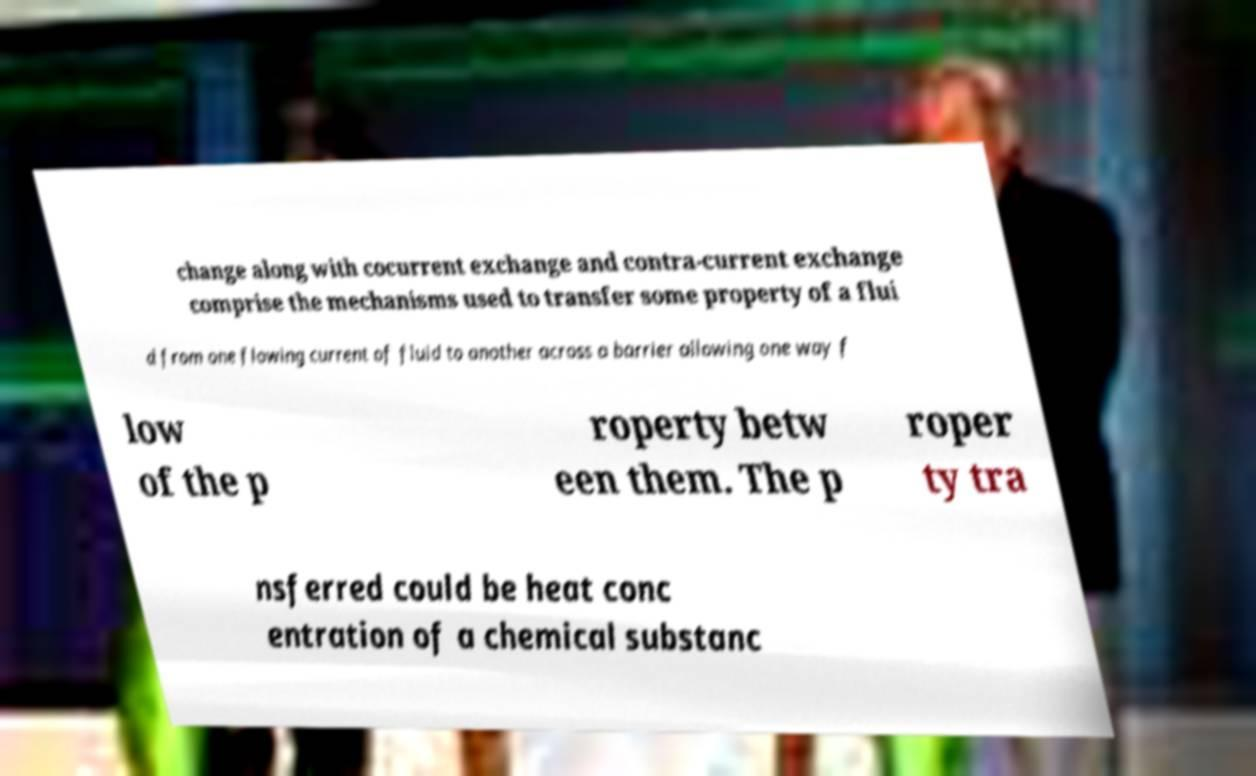Could you extract and type out the text from this image? change along with cocurrent exchange and contra-current exchange comprise the mechanisms used to transfer some property of a flui d from one flowing current of fluid to another across a barrier allowing one way f low of the p roperty betw een them. The p roper ty tra nsferred could be heat conc entration of a chemical substanc 